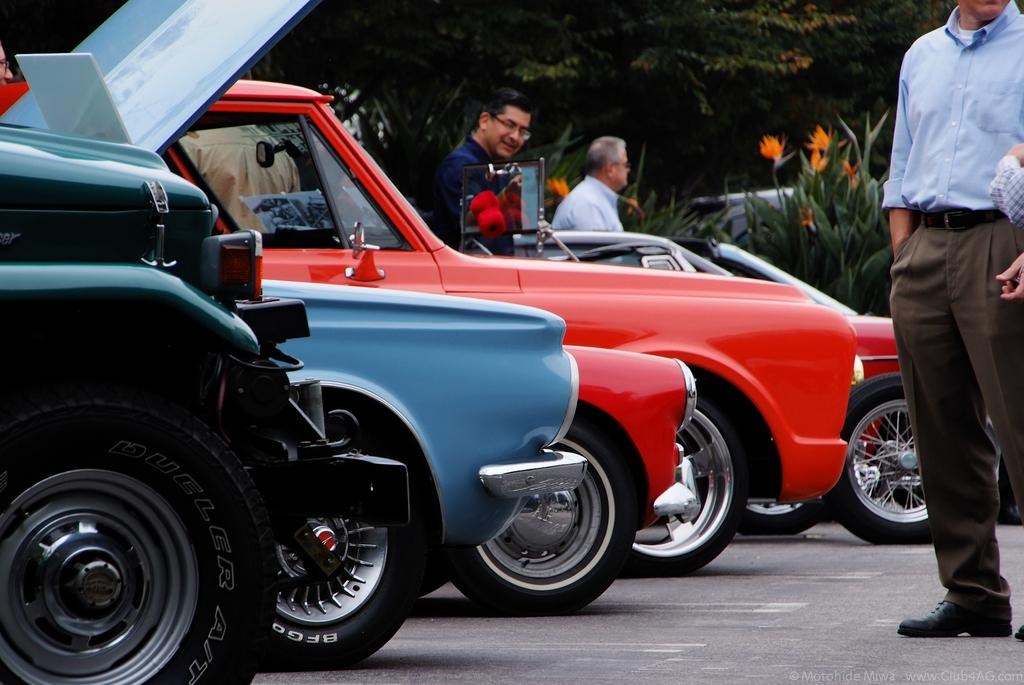What is happening on the road in the image? There are vehicles and persons on the road in the image. What can be seen in the background of the image? There are plants with flowers and trees in the background of the image. Where is the mailbox located in the image? There is no mailbox present in the image. In which direction are the vehicles and persons moving in the image? The direction of movement cannot be determined from the image alone, as it only shows a snapshot of the scene. 